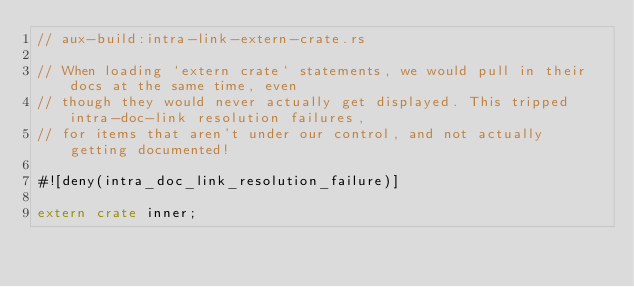Convert code to text. <code><loc_0><loc_0><loc_500><loc_500><_Rust_>// aux-build:intra-link-extern-crate.rs

// When loading `extern crate` statements, we would pull in their docs at the same time, even
// though they would never actually get displayed. This tripped intra-doc-link resolution failures,
// for items that aren't under our control, and not actually getting documented!

#![deny(intra_doc_link_resolution_failure)]

extern crate inner;
</code> 